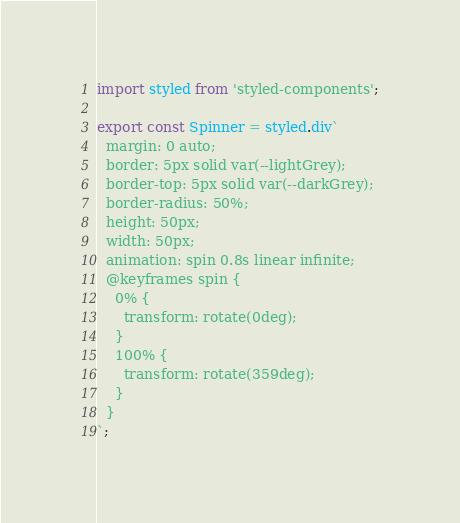Convert code to text. <code><loc_0><loc_0><loc_500><loc_500><_JavaScript_>import styled from 'styled-components';

export const Spinner = styled.div`
  margin: 0 auto;
  border: 5px solid var(--lightGrey);
  border-top: 5px solid var(--darkGrey);
  border-radius: 50%;
  height: 50px;
  width: 50px;
  animation: spin 0.8s linear infinite;
  @keyframes spin {
    0% {
      transform: rotate(0deg);
    }
    100% {
      transform: rotate(359deg);
    }
  }
`;
</code> 